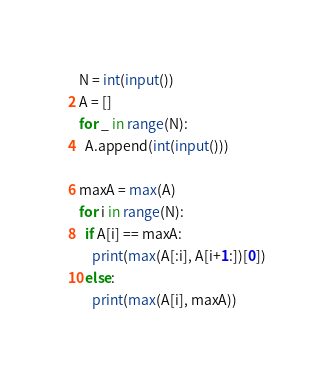<code> <loc_0><loc_0><loc_500><loc_500><_Python_>N = int(input())
A = []
for _ in range(N):
  A.append(int(input()))
  
maxA = max(A)
for i in range(N):
  if A[i] == maxA:
    print(max(A[:i], A[i+1:])[0])
  else:
    print(max(A[i], maxA))

</code> 